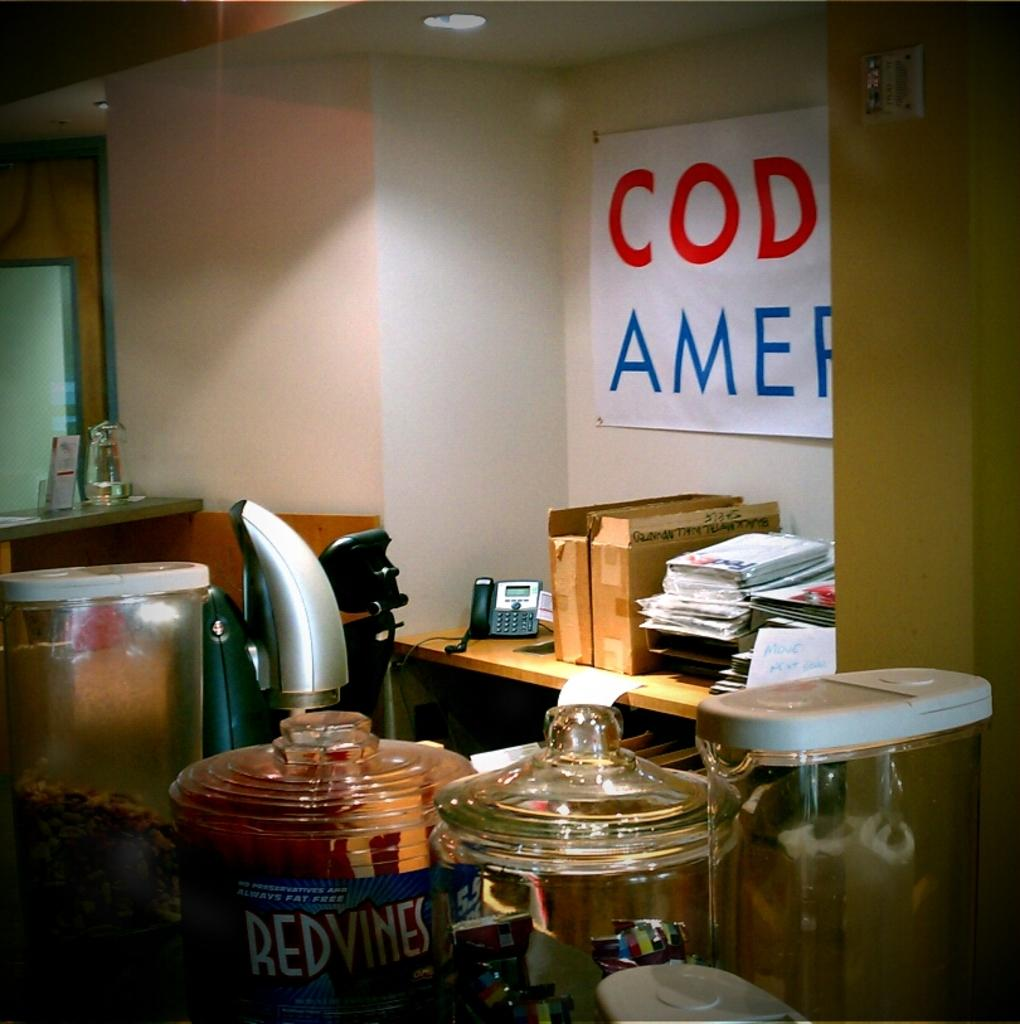<image>
Create a compact narrative representing the image presented. An office break room with a jar of Red Vines sitting on a table. 